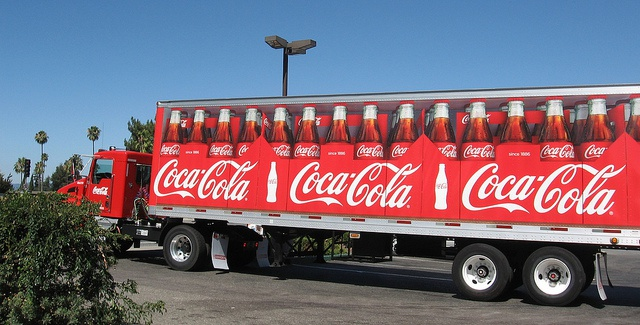Describe the objects in this image and their specific colors. I can see truck in gray, red, lightgray, and black tones, bottle in gray, lightgray, maroon, brown, and red tones, bottle in gray, maroon, brown, lightgray, and red tones, bottle in gray, lightgray, brown, maroon, and red tones, and bottle in gray, maroon, lightgray, red, and brown tones in this image. 